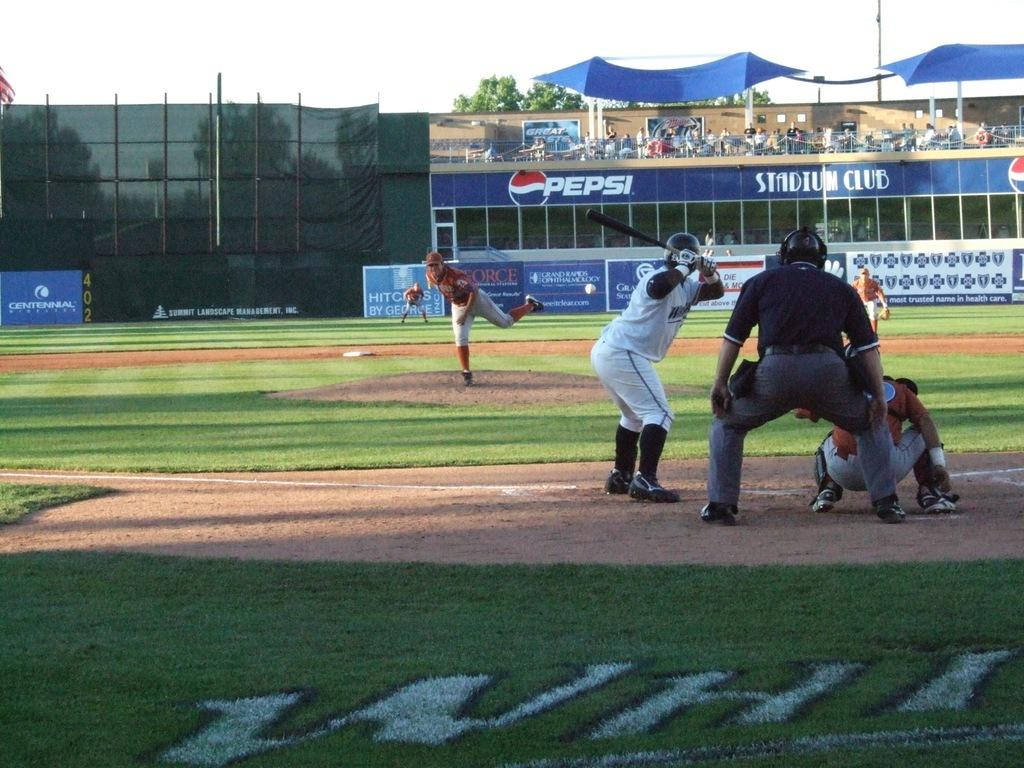<image>
Present a compact description of the photo's key features. A pitcher throwing at a batter with Pepsi advertisement and the Stadium Club in the background. 